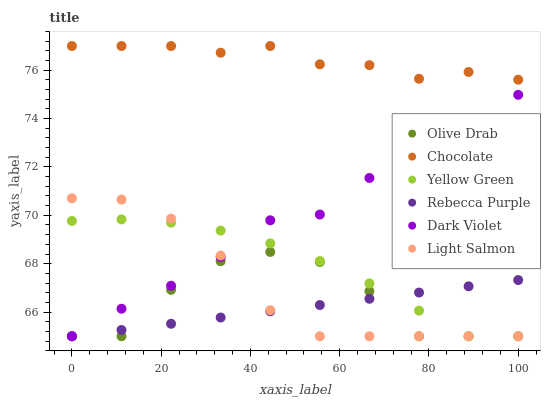Does Rebecca Purple have the minimum area under the curve?
Answer yes or no. Yes. Does Chocolate have the maximum area under the curve?
Answer yes or no. Yes. Does Yellow Green have the minimum area under the curve?
Answer yes or no. No. Does Yellow Green have the maximum area under the curve?
Answer yes or no. No. Is Rebecca Purple the smoothest?
Answer yes or no. Yes. Is Olive Drab the roughest?
Answer yes or no. Yes. Is Yellow Green the smoothest?
Answer yes or no. No. Is Yellow Green the roughest?
Answer yes or no. No. Does Light Salmon have the lowest value?
Answer yes or no. Yes. Does Chocolate have the lowest value?
Answer yes or no. No. Does Chocolate have the highest value?
Answer yes or no. Yes. Does Yellow Green have the highest value?
Answer yes or no. No. Is Dark Violet less than Chocolate?
Answer yes or no. Yes. Is Chocolate greater than Rebecca Purple?
Answer yes or no. Yes. Does Dark Violet intersect Light Salmon?
Answer yes or no. Yes. Is Dark Violet less than Light Salmon?
Answer yes or no. No. Is Dark Violet greater than Light Salmon?
Answer yes or no. No. Does Dark Violet intersect Chocolate?
Answer yes or no. No. 